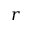<formula> <loc_0><loc_0><loc_500><loc_500>r</formula> 